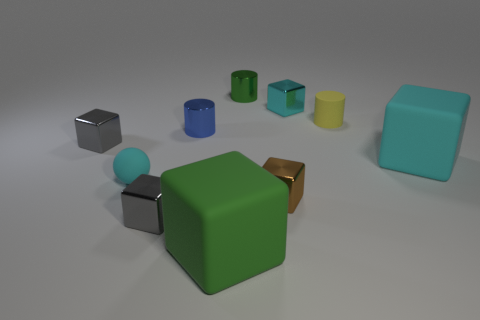Subtract all cyan rubber cubes. How many cubes are left? 5 Subtract all gray cubes. How many cubes are left? 4 Subtract all yellow blocks. Subtract all brown cylinders. How many blocks are left? 6 Subtract all spheres. How many objects are left? 9 Add 8 tiny green objects. How many tiny green objects are left? 9 Add 10 red cylinders. How many red cylinders exist? 10 Subtract 0 red blocks. How many objects are left? 10 Subtract all big blue rubber blocks. Subtract all yellow rubber cylinders. How many objects are left? 9 